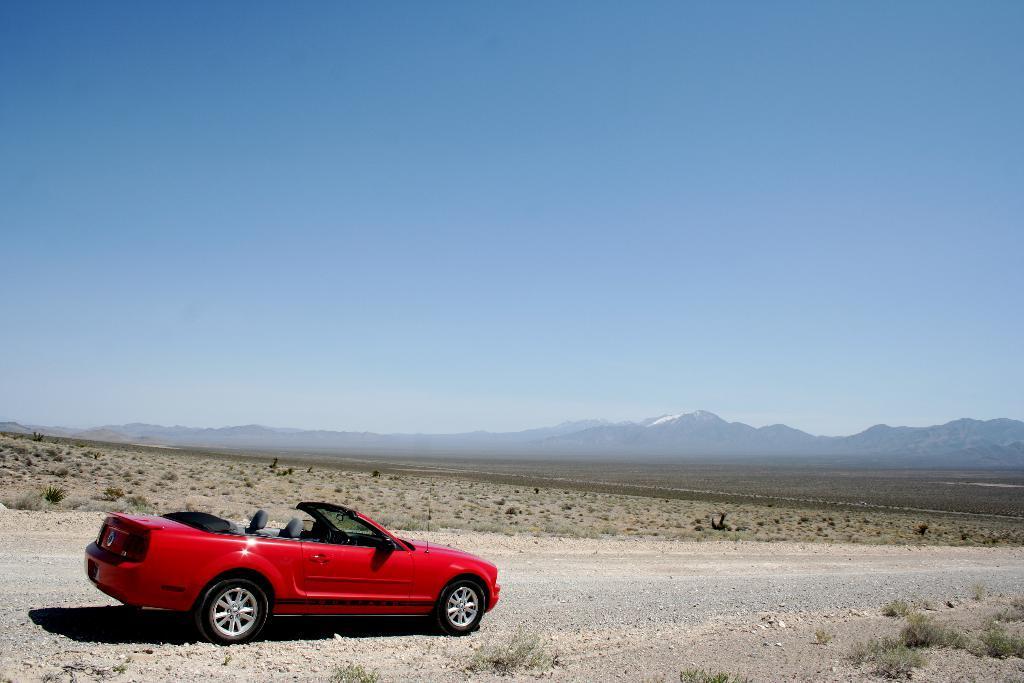Describe this image in one or two sentences. There is a car present on the road as we can see at the bottom of this image. We can see mountains in the background. The sky is at the top of this image. 